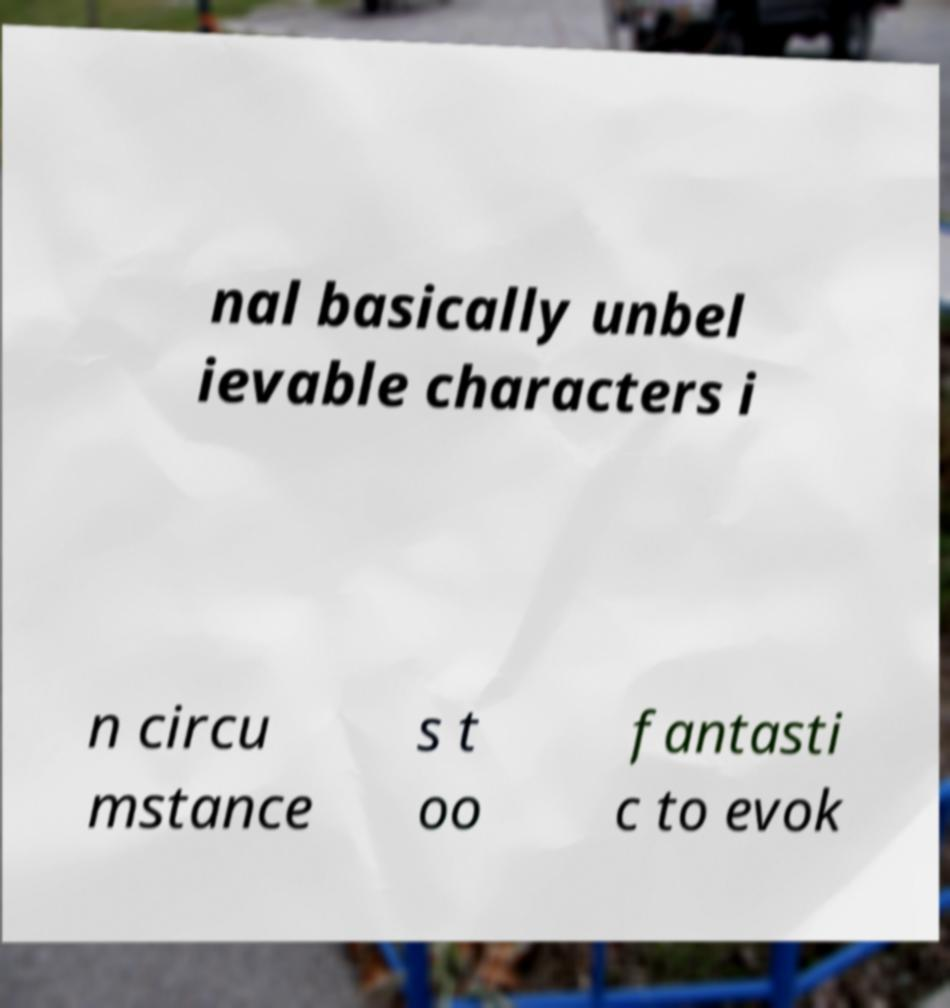What messages or text are displayed in this image? I need them in a readable, typed format. nal basically unbel ievable characters i n circu mstance s t oo fantasti c to evok 